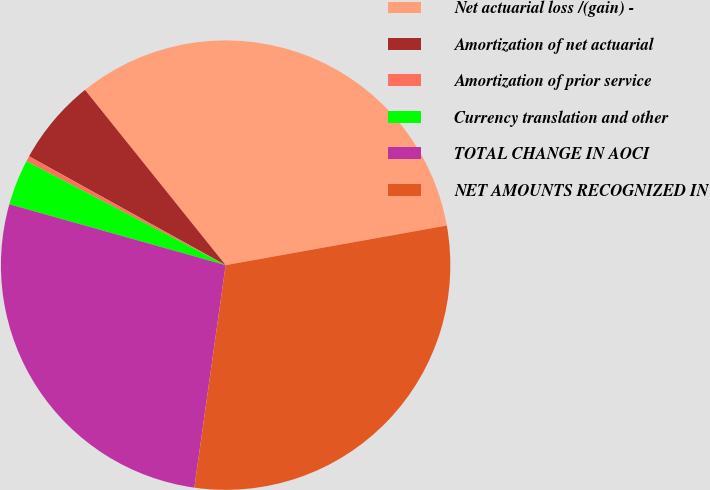<chart> <loc_0><loc_0><loc_500><loc_500><pie_chart><fcel>Net actuarial loss /(gain) -<fcel>Amortization of net actuarial<fcel>Amortization of prior service<fcel>Currency translation and other<fcel>TOTAL CHANGE IN AOCI<fcel>NET AMOUNTS RECOGNIZED IN<nl><fcel>32.95%<fcel>6.19%<fcel>0.39%<fcel>3.29%<fcel>27.15%<fcel>30.05%<nl></chart> 